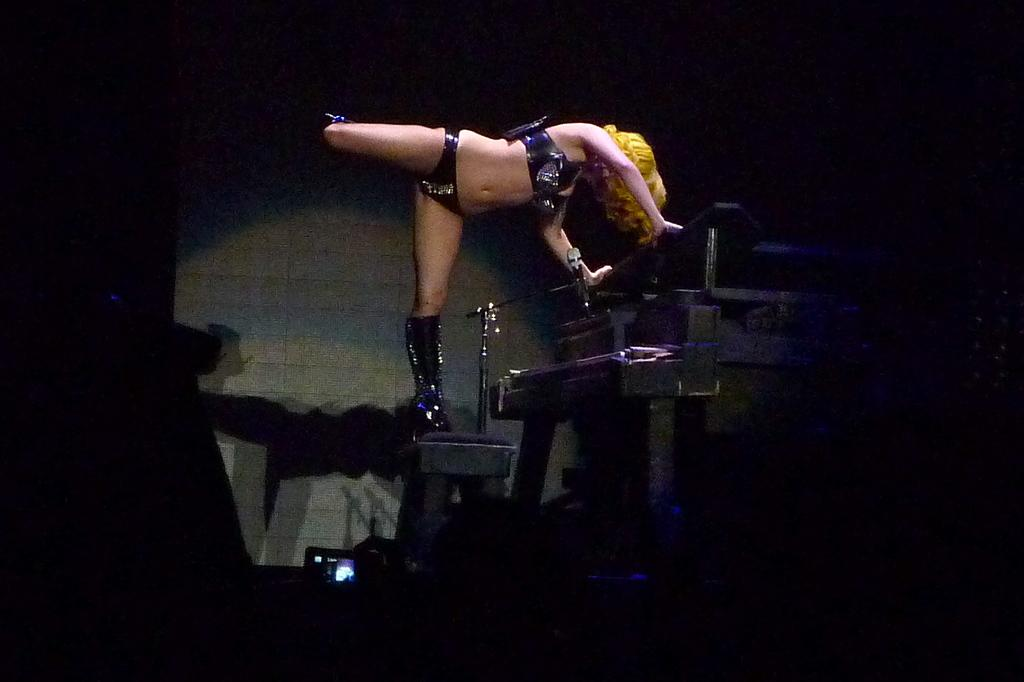Who is present in the image? There is a lady in the image. What object can be seen in the image? There is a camera in the image. What type of weather is depicted in the image? There is no weather depicted in the image, as it only features a lady and a camera. What type of minister is present in the image? There is no minister present in the image. 